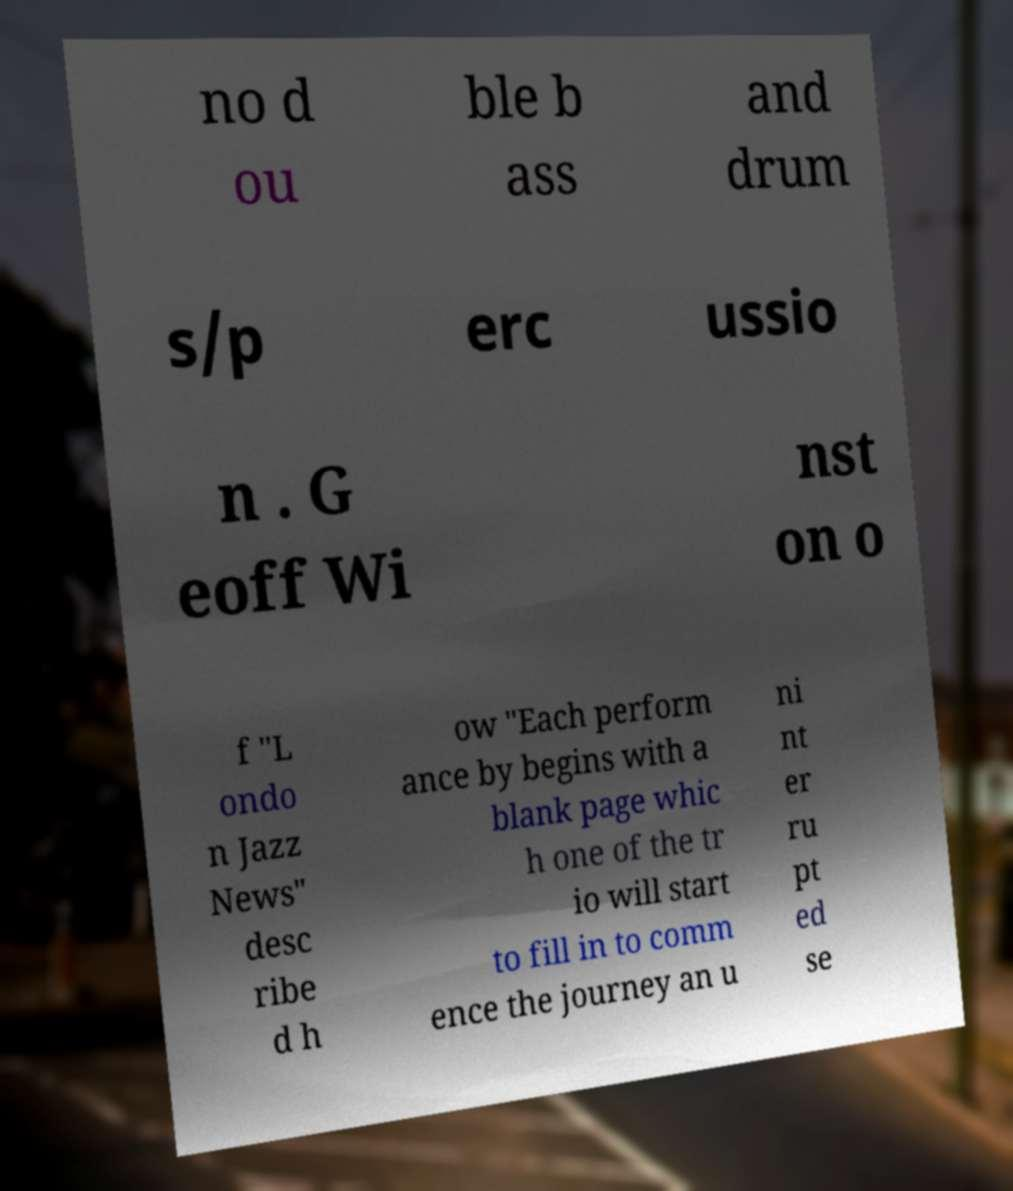Can you accurately transcribe the text from the provided image for me? no d ou ble b ass and drum s/p erc ussio n . G eoff Wi nst on o f "L ondo n Jazz News" desc ribe d h ow "Each perform ance by begins with a blank page whic h one of the tr io will start to fill in to comm ence the journey an u ni nt er ru pt ed se 